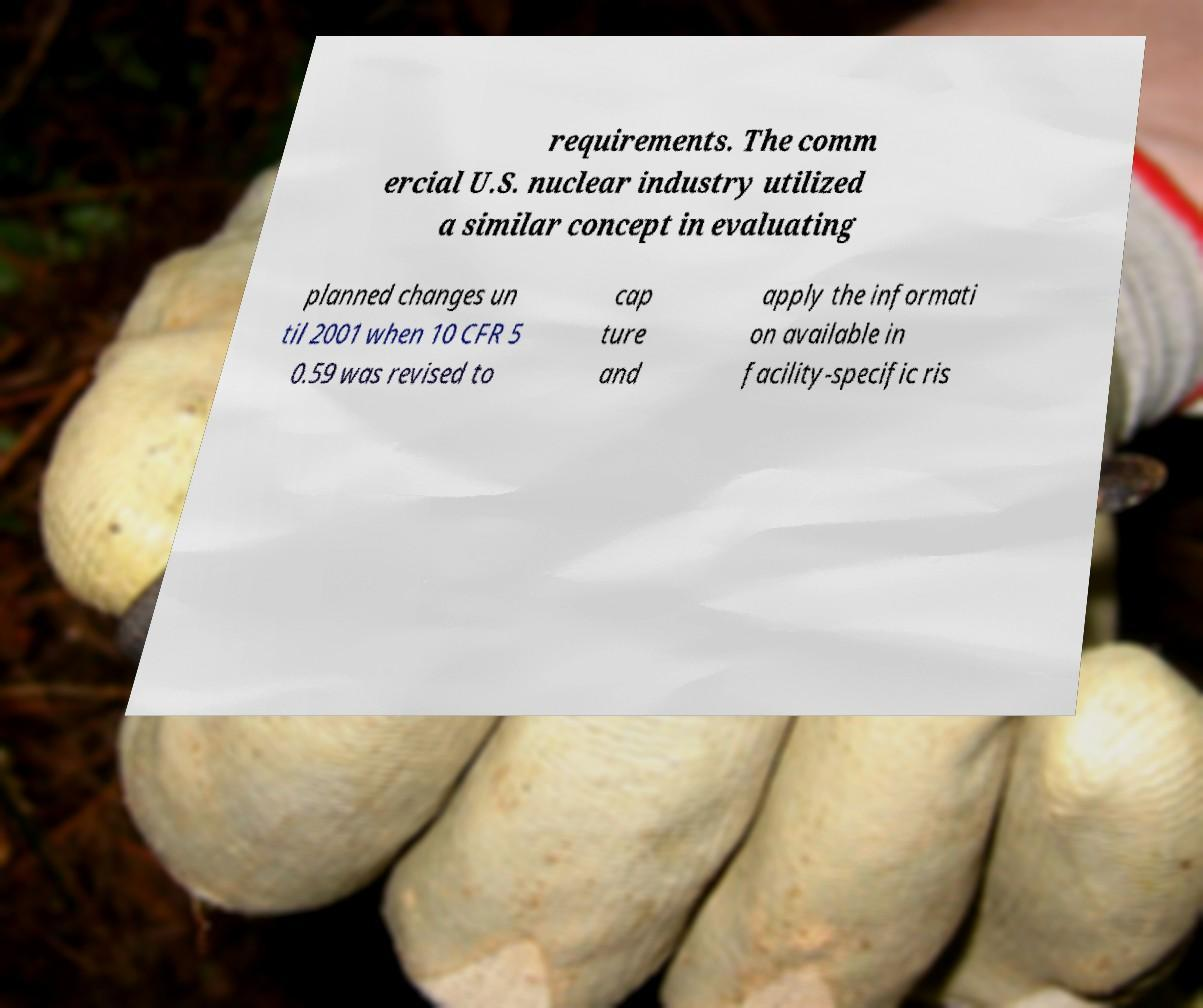Can you accurately transcribe the text from the provided image for me? requirements. The comm ercial U.S. nuclear industry utilized a similar concept in evaluating planned changes un til 2001 when 10 CFR 5 0.59 was revised to cap ture and apply the informati on available in facility-specific ris 